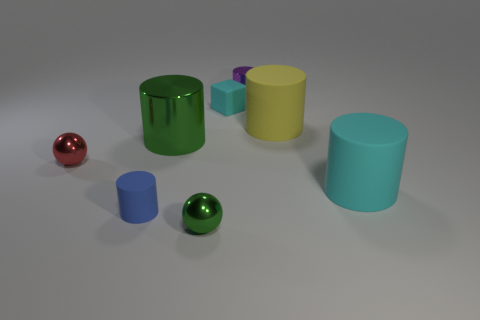Subtract all cyan rubber cylinders. How many cylinders are left? 4 Subtract all green cylinders. How many cylinders are left? 4 Subtract all gray cylinders. Subtract all brown cubes. How many cylinders are left? 5 Add 2 big red metal cylinders. How many objects exist? 10 Subtract all cylinders. How many objects are left? 3 Subtract 0 yellow cubes. How many objects are left? 8 Subtract all tiny cylinders. Subtract all green objects. How many objects are left? 4 Add 4 tiny green objects. How many tiny green objects are left? 5 Add 6 small cyan objects. How many small cyan objects exist? 7 